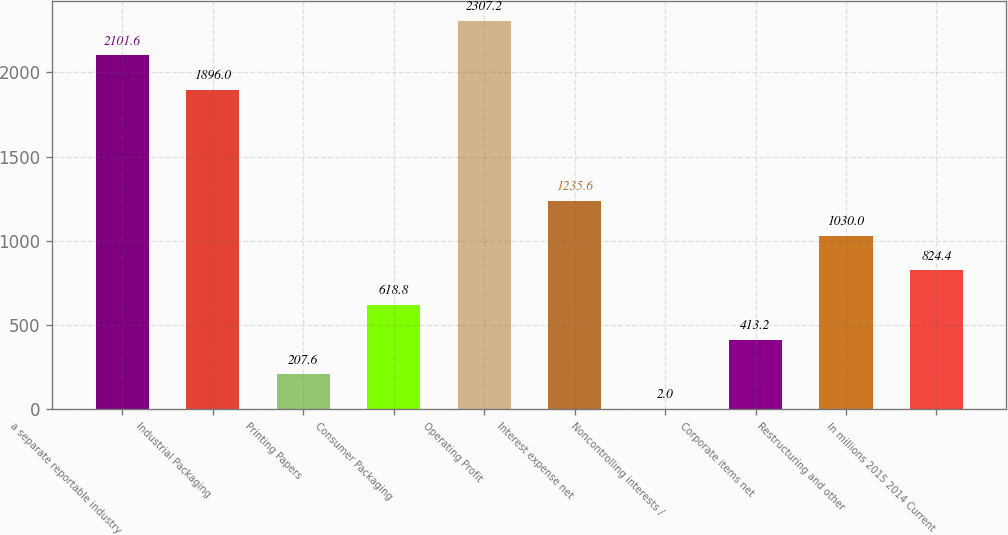Convert chart. <chart><loc_0><loc_0><loc_500><loc_500><bar_chart><fcel>a separate reportable industry<fcel>Industrial Packaging<fcel>Printing Papers<fcel>Consumer Packaging<fcel>Operating Profit<fcel>Interest expense net<fcel>Noncontrolling interests /<fcel>Corporate items net<fcel>Restructuring and other<fcel>In millions 2015 2014 Current<nl><fcel>2101.6<fcel>1896<fcel>207.6<fcel>618.8<fcel>2307.2<fcel>1235.6<fcel>2<fcel>413.2<fcel>1030<fcel>824.4<nl></chart> 